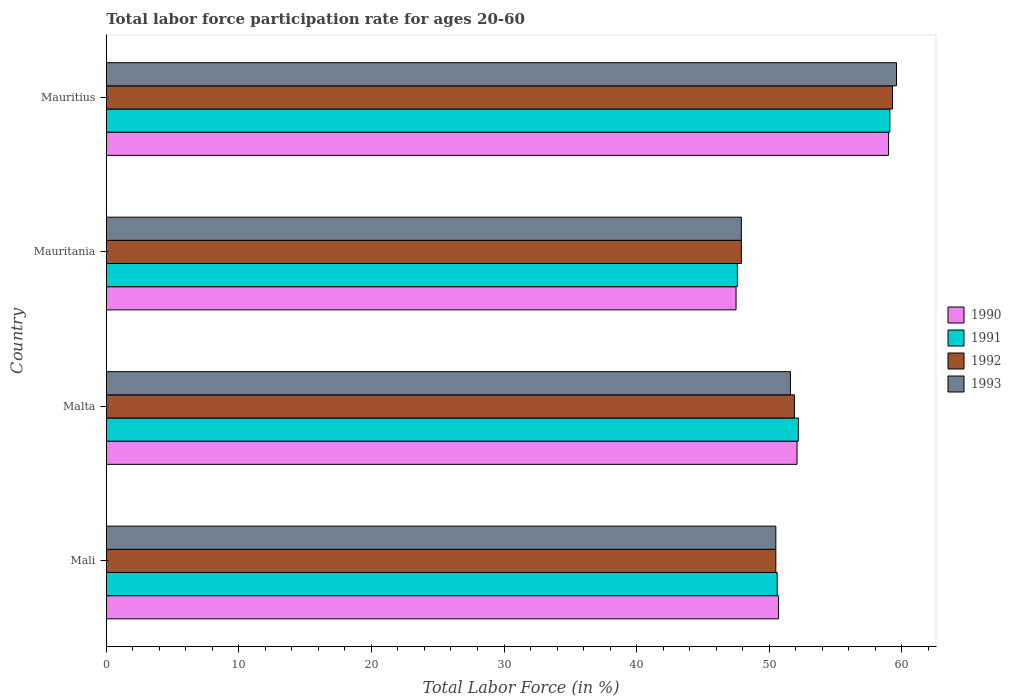How many different coloured bars are there?
Make the answer very short. 4. How many bars are there on the 2nd tick from the bottom?
Give a very brief answer. 4. What is the label of the 2nd group of bars from the top?
Make the answer very short. Mauritania. In how many cases, is the number of bars for a given country not equal to the number of legend labels?
Make the answer very short. 0. What is the labor force participation rate in 1993 in Mali?
Ensure brevity in your answer.  50.5. Across all countries, what is the minimum labor force participation rate in 1993?
Offer a terse response. 47.9. In which country was the labor force participation rate in 1991 maximum?
Make the answer very short. Mauritius. In which country was the labor force participation rate in 1992 minimum?
Make the answer very short. Mauritania. What is the total labor force participation rate in 1993 in the graph?
Ensure brevity in your answer.  209.6. What is the difference between the labor force participation rate in 1990 in Mauritania and that in Mauritius?
Offer a very short reply. -11.5. What is the average labor force participation rate in 1991 per country?
Offer a very short reply. 52.37. What is the difference between the labor force participation rate in 1991 and labor force participation rate in 1992 in Malta?
Offer a terse response. 0.3. What is the ratio of the labor force participation rate in 1993 in Malta to that in Mauritania?
Your answer should be compact. 1.08. Is the difference between the labor force participation rate in 1991 in Malta and Mauritania greater than the difference between the labor force participation rate in 1992 in Malta and Mauritania?
Provide a short and direct response. Yes. What is the difference between the highest and the second highest labor force participation rate in 1991?
Keep it short and to the point. 6.9. What does the 3rd bar from the bottom in Mauritania represents?
Your answer should be compact. 1992. What is the difference between two consecutive major ticks on the X-axis?
Provide a succinct answer. 10. Are the values on the major ticks of X-axis written in scientific E-notation?
Make the answer very short. No. Does the graph contain grids?
Your answer should be very brief. No. How many legend labels are there?
Your response must be concise. 4. What is the title of the graph?
Give a very brief answer. Total labor force participation rate for ages 20-60. What is the label or title of the X-axis?
Make the answer very short. Total Labor Force (in %). What is the label or title of the Y-axis?
Provide a short and direct response. Country. What is the Total Labor Force (in %) in 1990 in Mali?
Provide a succinct answer. 50.7. What is the Total Labor Force (in %) of 1991 in Mali?
Give a very brief answer. 50.6. What is the Total Labor Force (in %) in 1992 in Mali?
Give a very brief answer. 50.5. What is the Total Labor Force (in %) in 1993 in Mali?
Offer a terse response. 50.5. What is the Total Labor Force (in %) in 1990 in Malta?
Your answer should be compact. 52.1. What is the Total Labor Force (in %) of 1991 in Malta?
Offer a very short reply. 52.2. What is the Total Labor Force (in %) of 1992 in Malta?
Your answer should be very brief. 51.9. What is the Total Labor Force (in %) of 1993 in Malta?
Offer a terse response. 51.6. What is the Total Labor Force (in %) of 1990 in Mauritania?
Ensure brevity in your answer.  47.5. What is the Total Labor Force (in %) in 1991 in Mauritania?
Make the answer very short. 47.6. What is the Total Labor Force (in %) in 1992 in Mauritania?
Your answer should be compact. 47.9. What is the Total Labor Force (in %) of 1993 in Mauritania?
Make the answer very short. 47.9. What is the Total Labor Force (in %) of 1990 in Mauritius?
Offer a very short reply. 59. What is the Total Labor Force (in %) in 1991 in Mauritius?
Provide a succinct answer. 59.1. What is the Total Labor Force (in %) in 1992 in Mauritius?
Make the answer very short. 59.3. What is the Total Labor Force (in %) in 1993 in Mauritius?
Offer a very short reply. 59.6. Across all countries, what is the maximum Total Labor Force (in %) in 1991?
Your answer should be very brief. 59.1. Across all countries, what is the maximum Total Labor Force (in %) of 1992?
Keep it short and to the point. 59.3. Across all countries, what is the maximum Total Labor Force (in %) of 1993?
Ensure brevity in your answer.  59.6. Across all countries, what is the minimum Total Labor Force (in %) in 1990?
Your answer should be very brief. 47.5. Across all countries, what is the minimum Total Labor Force (in %) in 1991?
Offer a terse response. 47.6. Across all countries, what is the minimum Total Labor Force (in %) of 1992?
Make the answer very short. 47.9. Across all countries, what is the minimum Total Labor Force (in %) in 1993?
Keep it short and to the point. 47.9. What is the total Total Labor Force (in %) in 1990 in the graph?
Give a very brief answer. 209.3. What is the total Total Labor Force (in %) of 1991 in the graph?
Ensure brevity in your answer.  209.5. What is the total Total Labor Force (in %) in 1992 in the graph?
Provide a succinct answer. 209.6. What is the total Total Labor Force (in %) in 1993 in the graph?
Offer a very short reply. 209.6. What is the difference between the Total Labor Force (in %) of 1990 in Mali and that in Malta?
Keep it short and to the point. -1.4. What is the difference between the Total Labor Force (in %) in 1991 in Mali and that in Malta?
Provide a short and direct response. -1.6. What is the difference between the Total Labor Force (in %) of 1992 in Mali and that in Malta?
Your response must be concise. -1.4. What is the difference between the Total Labor Force (in %) in 1993 in Mali and that in Malta?
Offer a terse response. -1.1. What is the difference between the Total Labor Force (in %) in 1992 in Mali and that in Mauritania?
Ensure brevity in your answer.  2.6. What is the difference between the Total Labor Force (in %) in 1993 in Mali and that in Mauritania?
Keep it short and to the point. 2.6. What is the difference between the Total Labor Force (in %) of 1993 in Mali and that in Mauritius?
Ensure brevity in your answer.  -9.1. What is the difference between the Total Labor Force (in %) in 1991 in Malta and that in Mauritania?
Your response must be concise. 4.6. What is the difference between the Total Labor Force (in %) in 1992 in Malta and that in Mauritania?
Make the answer very short. 4. What is the difference between the Total Labor Force (in %) in 1993 in Malta and that in Mauritania?
Offer a terse response. 3.7. What is the difference between the Total Labor Force (in %) in 1992 in Malta and that in Mauritius?
Make the answer very short. -7.4. What is the difference between the Total Labor Force (in %) of 1993 in Malta and that in Mauritius?
Your response must be concise. -8. What is the difference between the Total Labor Force (in %) of 1992 in Mauritania and that in Mauritius?
Give a very brief answer. -11.4. What is the difference between the Total Labor Force (in %) in 1993 in Mauritania and that in Mauritius?
Give a very brief answer. -11.7. What is the difference between the Total Labor Force (in %) in 1990 in Mali and the Total Labor Force (in %) in 1991 in Mauritania?
Keep it short and to the point. 3.1. What is the difference between the Total Labor Force (in %) in 1991 in Mali and the Total Labor Force (in %) in 1992 in Mauritania?
Your response must be concise. 2.7. What is the difference between the Total Labor Force (in %) of 1991 in Mali and the Total Labor Force (in %) of 1993 in Mauritania?
Provide a succinct answer. 2.7. What is the difference between the Total Labor Force (in %) of 1990 in Mali and the Total Labor Force (in %) of 1992 in Mauritius?
Provide a short and direct response. -8.6. What is the difference between the Total Labor Force (in %) in 1991 in Mali and the Total Labor Force (in %) in 1992 in Mauritius?
Provide a short and direct response. -8.7. What is the difference between the Total Labor Force (in %) in 1990 in Malta and the Total Labor Force (in %) in 1991 in Mauritania?
Provide a short and direct response. 4.5. What is the difference between the Total Labor Force (in %) of 1990 in Malta and the Total Labor Force (in %) of 1992 in Mauritania?
Keep it short and to the point. 4.2. What is the difference between the Total Labor Force (in %) of 1991 in Malta and the Total Labor Force (in %) of 1992 in Mauritania?
Ensure brevity in your answer.  4.3. What is the difference between the Total Labor Force (in %) of 1991 in Malta and the Total Labor Force (in %) of 1993 in Mauritius?
Provide a succinct answer. -7.4. What is the difference between the Total Labor Force (in %) in 1992 in Malta and the Total Labor Force (in %) in 1993 in Mauritius?
Offer a very short reply. -7.7. What is the difference between the Total Labor Force (in %) of 1991 in Mauritania and the Total Labor Force (in %) of 1993 in Mauritius?
Offer a very short reply. -12. What is the average Total Labor Force (in %) of 1990 per country?
Keep it short and to the point. 52.33. What is the average Total Labor Force (in %) in 1991 per country?
Your answer should be very brief. 52.38. What is the average Total Labor Force (in %) in 1992 per country?
Your response must be concise. 52.4. What is the average Total Labor Force (in %) in 1993 per country?
Give a very brief answer. 52.4. What is the difference between the Total Labor Force (in %) in 1990 and Total Labor Force (in %) in 1991 in Mali?
Your answer should be compact. 0.1. What is the difference between the Total Labor Force (in %) of 1990 and Total Labor Force (in %) of 1993 in Mali?
Keep it short and to the point. 0.2. What is the difference between the Total Labor Force (in %) in 1992 and Total Labor Force (in %) in 1993 in Malta?
Your answer should be very brief. 0.3. What is the difference between the Total Labor Force (in %) in 1991 and Total Labor Force (in %) in 1993 in Mauritania?
Offer a very short reply. -0.3. What is the difference between the Total Labor Force (in %) of 1990 and Total Labor Force (in %) of 1991 in Mauritius?
Make the answer very short. -0.1. What is the difference between the Total Labor Force (in %) of 1990 and Total Labor Force (in %) of 1992 in Mauritius?
Keep it short and to the point. -0.3. What is the difference between the Total Labor Force (in %) in 1991 and Total Labor Force (in %) in 1992 in Mauritius?
Give a very brief answer. -0.2. What is the difference between the Total Labor Force (in %) of 1991 and Total Labor Force (in %) of 1993 in Mauritius?
Your response must be concise. -0.5. What is the difference between the Total Labor Force (in %) in 1992 and Total Labor Force (in %) in 1993 in Mauritius?
Give a very brief answer. -0.3. What is the ratio of the Total Labor Force (in %) of 1990 in Mali to that in Malta?
Make the answer very short. 0.97. What is the ratio of the Total Labor Force (in %) in 1991 in Mali to that in Malta?
Keep it short and to the point. 0.97. What is the ratio of the Total Labor Force (in %) in 1993 in Mali to that in Malta?
Offer a terse response. 0.98. What is the ratio of the Total Labor Force (in %) in 1990 in Mali to that in Mauritania?
Your response must be concise. 1.07. What is the ratio of the Total Labor Force (in %) of 1991 in Mali to that in Mauritania?
Offer a terse response. 1.06. What is the ratio of the Total Labor Force (in %) in 1992 in Mali to that in Mauritania?
Give a very brief answer. 1.05. What is the ratio of the Total Labor Force (in %) in 1993 in Mali to that in Mauritania?
Your response must be concise. 1.05. What is the ratio of the Total Labor Force (in %) in 1990 in Mali to that in Mauritius?
Offer a terse response. 0.86. What is the ratio of the Total Labor Force (in %) in 1991 in Mali to that in Mauritius?
Provide a succinct answer. 0.86. What is the ratio of the Total Labor Force (in %) of 1992 in Mali to that in Mauritius?
Ensure brevity in your answer.  0.85. What is the ratio of the Total Labor Force (in %) in 1993 in Mali to that in Mauritius?
Give a very brief answer. 0.85. What is the ratio of the Total Labor Force (in %) in 1990 in Malta to that in Mauritania?
Ensure brevity in your answer.  1.1. What is the ratio of the Total Labor Force (in %) in 1991 in Malta to that in Mauritania?
Make the answer very short. 1.1. What is the ratio of the Total Labor Force (in %) in 1992 in Malta to that in Mauritania?
Make the answer very short. 1.08. What is the ratio of the Total Labor Force (in %) in 1993 in Malta to that in Mauritania?
Make the answer very short. 1.08. What is the ratio of the Total Labor Force (in %) in 1990 in Malta to that in Mauritius?
Your answer should be very brief. 0.88. What is the ratio of the Total Labor Force (in %) in 1991 in Malta to that in Mauritius?
Offer a terse response. 0.88. What is the ratio of the Total Labor Force (in %) in 1992 in Malta to that in Mauritius?
Offer a terse response. 0.88. What is the ratio of the Total Labor Force (in %) in 1993 in Malta to that in Mauritius?
Offer a very short reply. 0.87. What is the ratio of the Total Labor Force (in %) of 1990 in Mauritania to that in Mauritius?
Offer a very short reply. 0.81. What is the ratio of the Total Labor Force (in %) in 1991 in Mauritania to that in Mauritius?
Keep it short and to the point. 0.81. What is the ratio of the Total Labor Force (in %) in 1992 in Mauritania to that in Mauritius?
Offer a terse response. 0.81. What is the ratio of the Total Labor Force (in %) in 1993 in Mauritania to that in Mauritius?
Ensure brevity in your answer.  0.8. What is the difference between the highest and the second highest Total Labor Force (in %) in 1990?
Ensure brevity in your answer.  6.9. What is the difference between the highest and the second highest Total Labor Force (in %) in 1993?
Make the answer very short. 8. What is the difference between the highest and the lowest Total Labor Force (in %) of 1990?
Provide a succinct answer. 11.5. What is the difference between the highest and the lowest Total Labor Force (in %) in 1992?
Offer a very short reply. 11.4. 